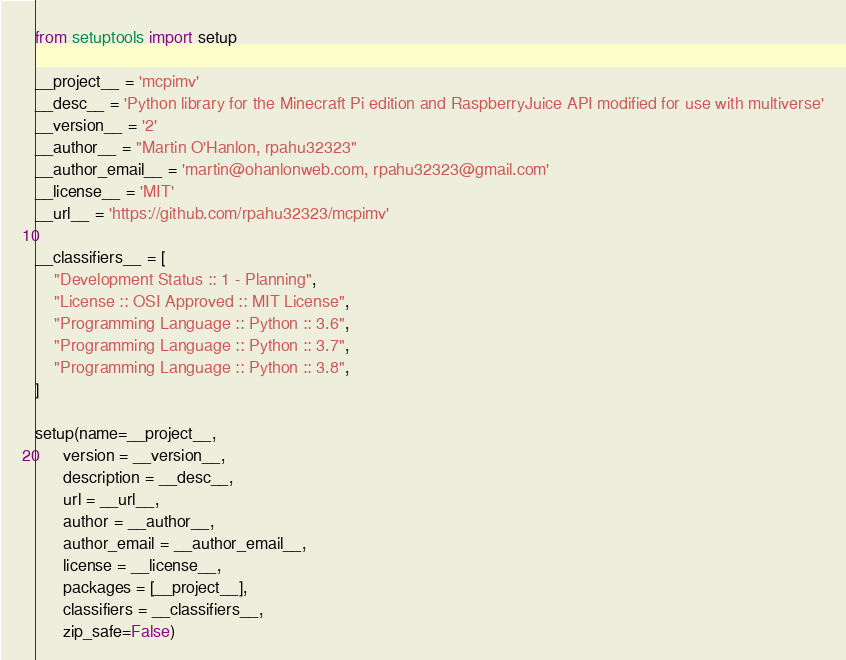Convert code to text. <code><loc_0><loc_0><loc_500><loc_500><_Python_>from setuptools import setup

__project__ = 'mcpimv'
__desc__ = 'Python library for the Minecraft Pi edition and RaspberryJuice API modified for use with multiverse'
__version__ = '2'
__author__ = "Martin O'Hanlon, rpahu32323"
__author_email__ = 'martin@ohanlonweb.com, rpahu32323@gmail.com'
__license__ = 'MIT'
__url__ = 'https://github.com/rpahu32323/mcpimv'

__classifiers__ = [
    "Development Status :: 1 - Planning",
    "License :: OSI Approved :: MIT License",
    "Programming Language :: Python :: 3.6",
    "Programming Language :: Python :: 3.7",
    "Programming Language :: Python :: 3.8",
]

setup(name=__project__,
      version = __version__,
      description = __desc__,
      url = __url__,
      author = __author__,
      author_email = __author_email__,
      license = __license__,
      packages = [__project__],
      classifiers = __classifiers__,
      zip_safe=False)
</code> 